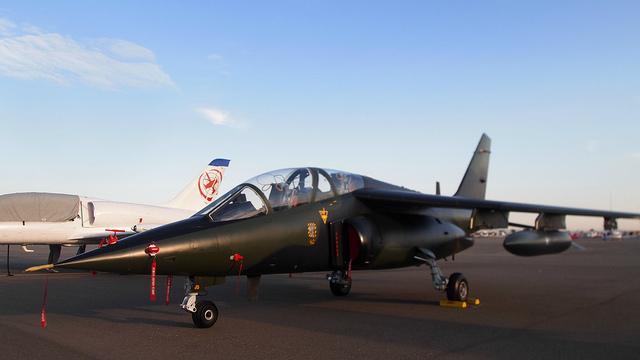Could this be a cargo plane?
Give a very brief answer. No. Are both planes the same color?
Short answer required. No. What is the plane designed for?
Quick response, please. Military. Is the plane at a airport?
Write a very short answer. Yes. What color is the plane?
Be succinct. Black. 